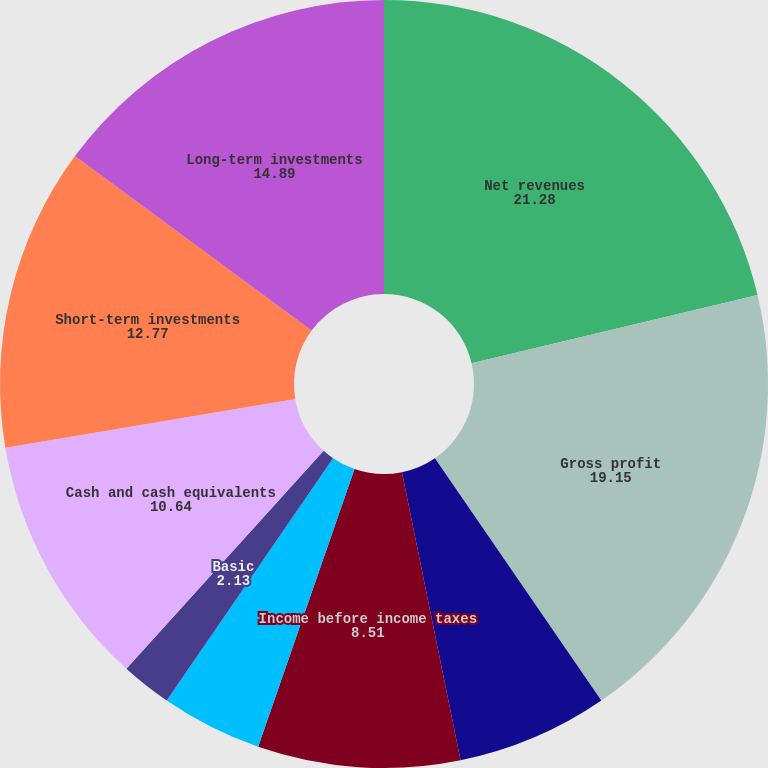<chart> <loc_0><loc_0><loc_500><loc_500><pie_chart><fcel>Net revenues<fcel>Gross profit<fcel>Income from operations<fcel>Income before income taxes<fcel>Net income<fcel>Basic<fcel>Diluted<fcel>Cash and cash equivalents<fcel>Short-term investments<fcel>Long-term investments<nl><fcel>21.28%<fcel>19.15%<fcel>6.38%<fcel>8.51%<fcel>4.26%<fcel>2.13%<fcel>0.0%<fcel>10.64%<fcel>12.77%<fcel>14.89%<nl></chart> 